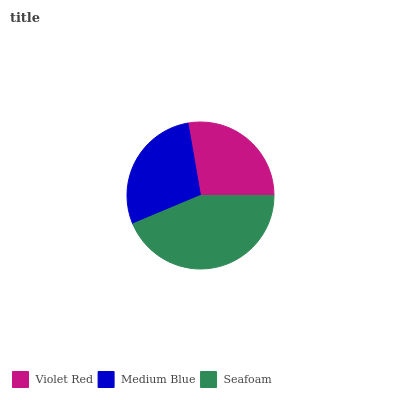Is Violet Red the minimum?
Answer yes or no. Yes. Is Seafoam the maximum?
Answer yes or no. Yes. Is Medium Blue the minimum?
Answer yes or no. No. Is Medium Blue the maximum?
Answer yes or no. No. Is Medium Blue greater than Violet Red?
Answer yes or no. Yes. Is Violet Red less than Medium Blue?
Answer yes or no. Yes. Is Violet Red greater than Medium Blue?
Answer yes or no. No. Is Medium Blue less than Violet Red?
Answer yes or no. No. Is Medium Blue the high median?
Answer yes or no. Yes. Is Medium Blue the low median?
Answer yes or no. Yes. Is Violet Red the high median?
Answer yes or no. No. Is Seafoam the low median?
Answer yes or no. No. 